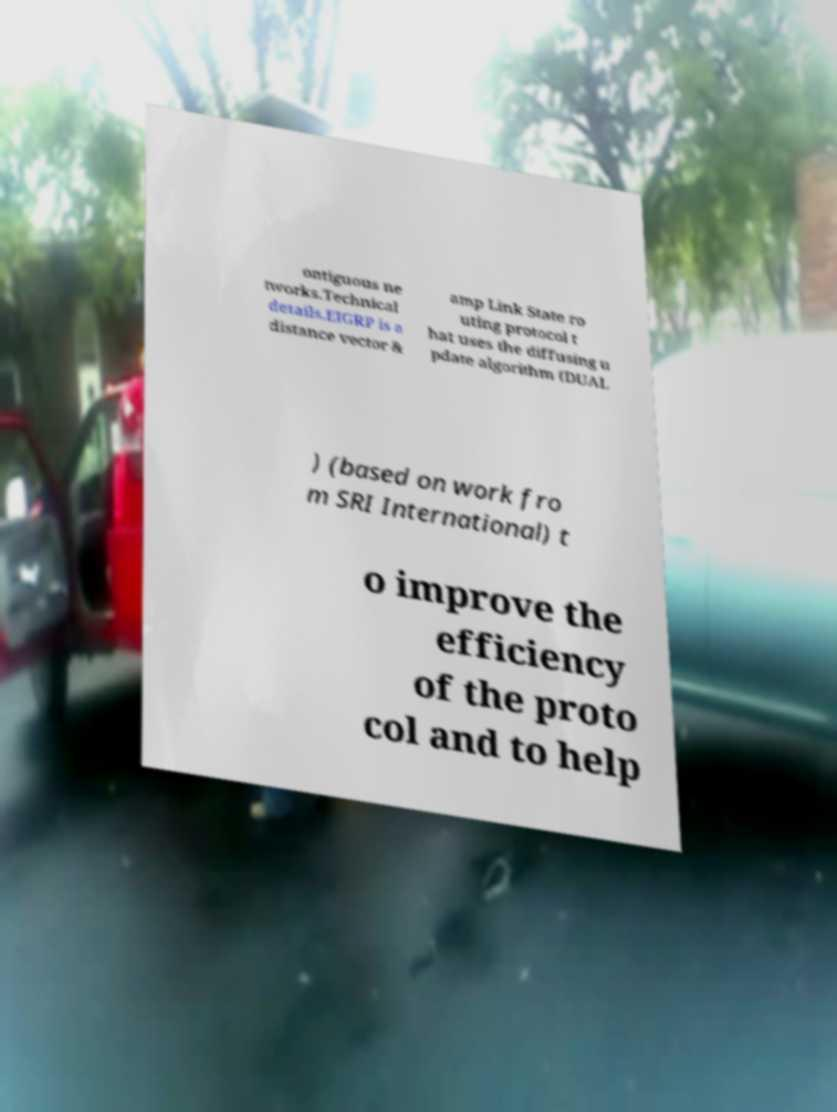Please identify and transcribe the text found in this image. ontiguous ne tworks.Technical details.EIGRP is a distance vector & amp Link State ro uting protocol t hat uses the diffusing u pdate algorithm (DUAL ) (based on work fro m SRI International) t o improve the efficiency of the proto col and to help 